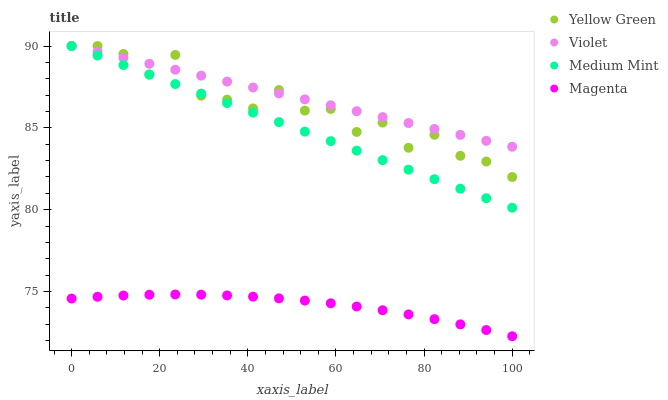Does Magenta have the minimum area under the curve?
Answer yes or no. Yes. Does Violet have the maximum area under the curve?
Answer yes or no. Yes. Does Yellow Green have the minimum area under the curve?
Answer yes or no. No. Does Yellow Green have the maximum area under the curve?
Answer yes or no. No. Is Medium Mint the smoothest?
Answer yes or no. Yes. Is Yellow Green the roughest?
Answer yes or no. Yes. Is Magenta the smoothest?
Answer yes or no. No. Is Magenta the roughest?
Answer yes or no. No. Does Magenta have the lowest value?
Answer yes or no. Yes. Does Yellow Green have the lowest value?
Answer yes or no. No. Does Violet have the highest value?
Answer yes or no. Yes. Does Magenta have the highest value?
Answer yes or no. No. Is Magenta less than Violet?
Answer yes or no. Yes. Is Violet greater than Magenta?
Answer yes or no. Yes. Does Medium Mint intersect Violet?
Answer yes or no. Yes. Is Medium Mint less than Violet?
Answer yes or no. No. Is Medium Mint greater than Violet?
Answer yes or no. No. Does Magenta intersect Violet?
Answer yes or no. No. 